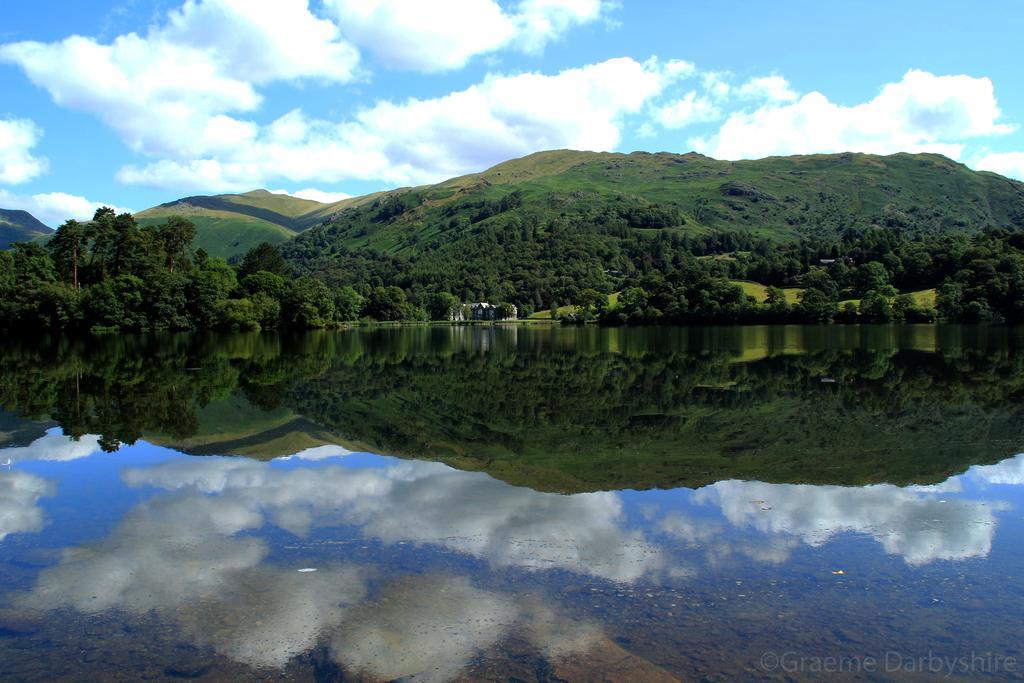Could you give a brief overview of what you see in this image? In this picture we can see water, trees, hills and clouds. 